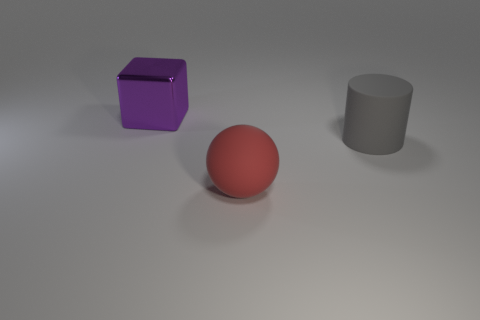Are there fewer large shiny things that are to the left of the block than gray objects left of the big red matte ball?
Provide a succinct answer. No. Does the object that is to the right of the matte ball have the same size as the purple metal cube?
Make the answer very short. Yes. Are there fewer gray matte objects left of the cylinder than big gray matte things?
Make the answer very short. Yes. Is there any other thing that is the same size as the rubber sphere?
Make the answer very short. Yes. What is the size of the object to the left of the rubber thing in front of the gray matte object?
Your response must be concise. Large. Is there anything else that is the same shape as the big gray matte thing?
Offer a very short reply. No. Is the number of large cyan rubber blocks less than the number of red objects?
Your answer should be compact. Yes. What is the material of the object that is both to the left of the large matte cylinder and in front of the purple object?
Provide a short and direct response. Rubber. Is there a big thing that is to the right of the big rubber thing that is to the left of the gray object?
Ensure brevity in your answer.  Yes. How many things are shiny cubes or large rubber cylinders?
Offer a terse response. 2. 